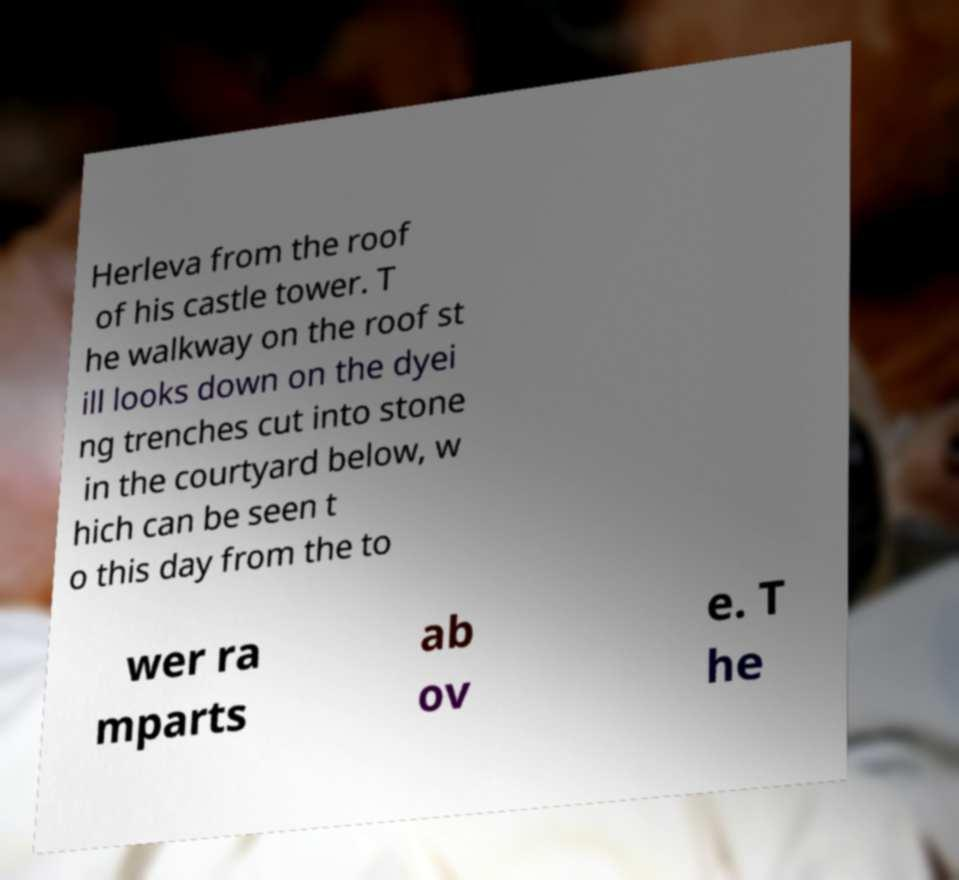What messages or text are displayed in this image? I need them in a readable, typed format. Herleva from the roof of his castle tower. T he walkway on the roof st ill looks down on the dyei ng trenches cut into stone in the courtyard below, w hich can be seen t o this day from the to wer ra mparts ab ov e. T he 